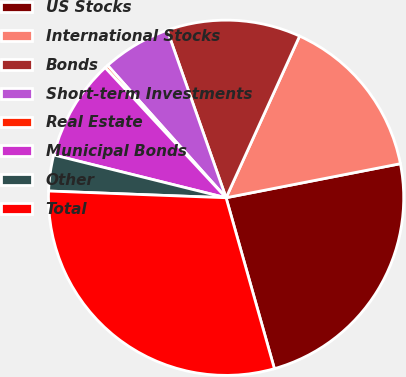Convert chart to OTSL. <chart><loc_0><loc_0><loc_500><loc_500><pie_chart><fcel>US Stocks<fcel>International Stocks<fcel>Bonds<fcel>Short-term Investments<fcel>Real Estate<fcel>Municipal Bonds<fcel>Other<fcel>Total<nl><fcel>23.69%<fcel>15.14%<fcel>12.17%<fcel>6.24%<fcel>0.3%<fcel>9.21%<fcel>3.27%<fcel>29.99%<nl></chart> 